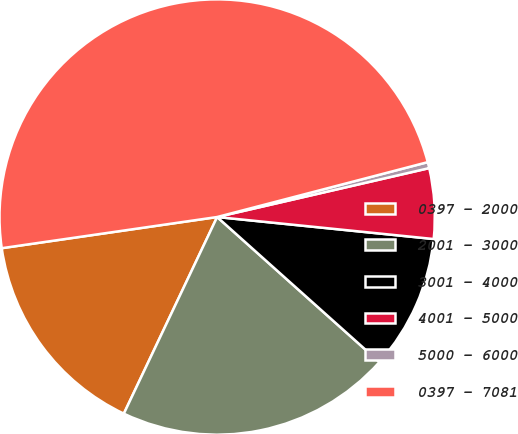Convert chart to OTSL. <chart><loc_0><loc_0><loc_500><loc_500><pie_chart><fcel>0397 - 2000<fcel>2001 - 3000<fcel>3001 - 4000<fcel>4001 - 5000<fcel>5000 - 6000<fcel>0397 - 7081<nl><fcel>15.66%<fcel>20.44%<fcel>10.0%<fcel>5.22%<fcel>0.45%<fcel>48.23%<nl></chart> 